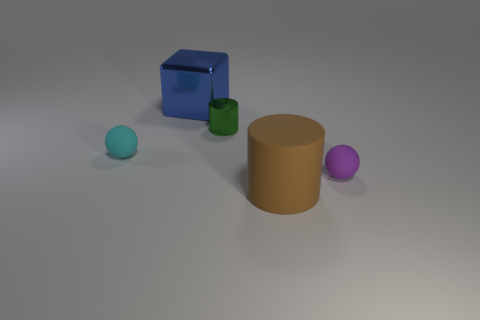Add 5 cyan matte spheres. How many objects exist? 10 Subtract all balls. How many objects are left? 3 Add 1 brown matte things. How many brown matte things exist? 2 Subtract 0 yellow blocks. How many objects are left? 5 Subtract all small cyan rubber objects. Subtract all tiny purple objects. How many objects are left? 3 Add 2 large brown rubber cylinders. How many large brown rubber cylinders are left? 3 